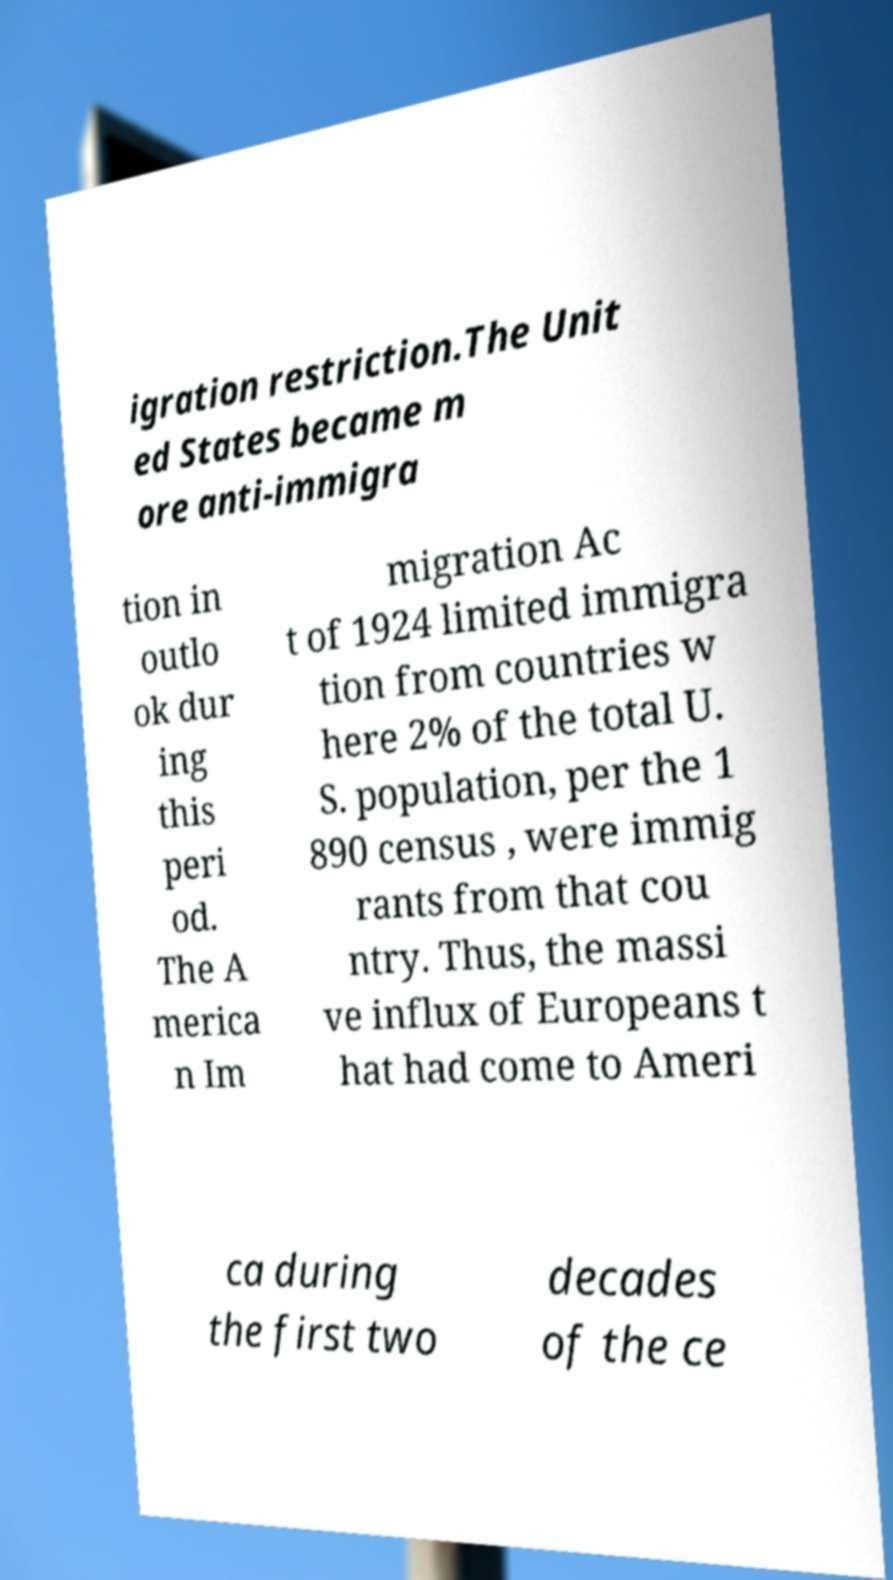I need the written content from this picture converted into text. Can you do that? igration restriction.The Unit ed States became m ore anti-immigra tion in outlo ok dur ing this peri od. The A merica n Im migration Ac t of 1924 limited immigra tion from countries w here 2% of the total U. S. population, per the 1 890 census , were immig rants from that cou ntry. Thus, the massi ve influx of Europeans t hat had come to Ameri ca during the first two decades of the ce 